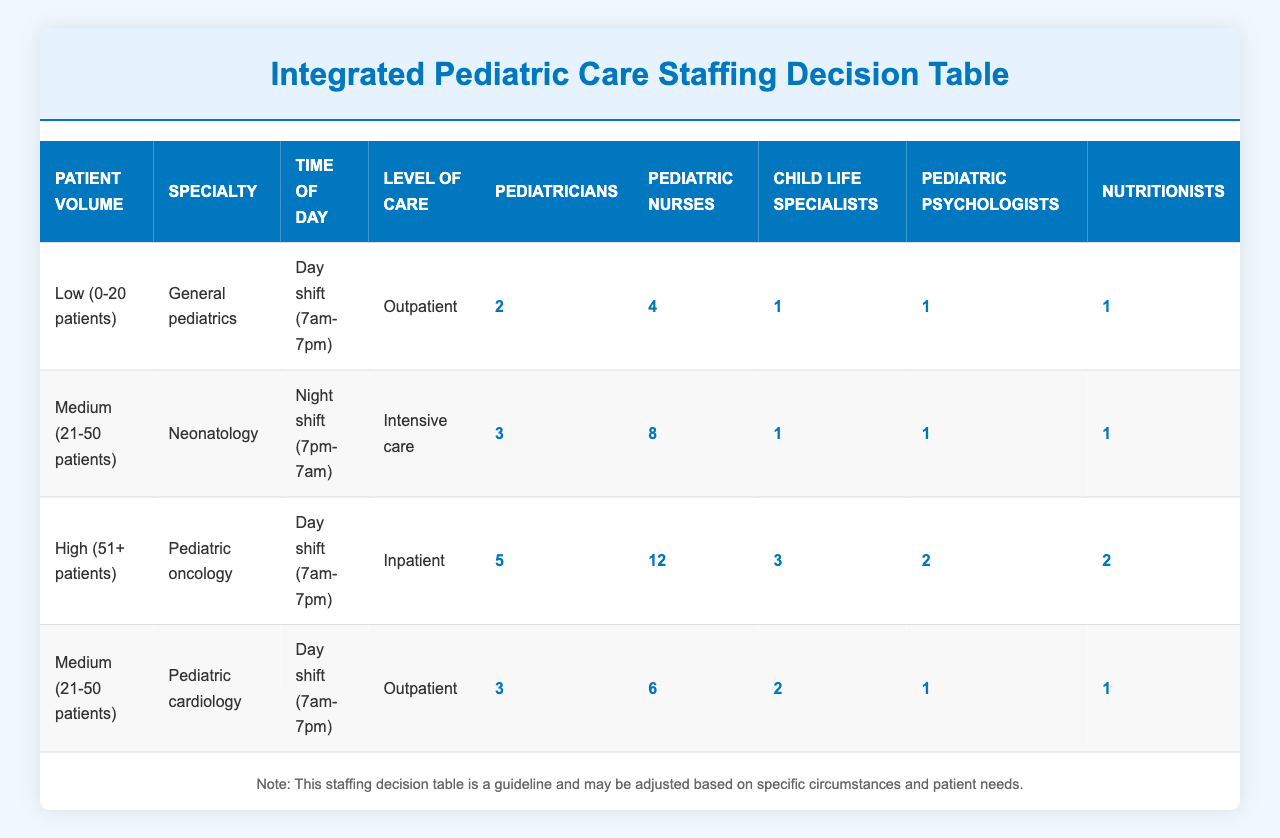What is the staffing allocation for pediatric psychologists during medium patient volume for pediatric cardiology? For medium patient volume (21-50 patients) in pediatric cardiology, the staffing table indicates that there is 1 pediatric psychologist allocated.
Answer: 1 How many pediatric nurses are needed for high patient volume in pediatric oncology? The table specifies that during high patient volume (51+ patients) in pediatric oncology, the required number of pediatric nurses is 12.
Answer: 12 Are there more pediatricians allocated for outpatient or inpatient care during the day shift? On the day shift, pediatricians allocated for outpatient care (low volume general pediatrics needs 2 and medium volume pediatric cardiology needs 3) total 5, whereas for inpatient care (high volume pediatric oncology) there are 5 pediatricians. Since both totals are equal at 5, the answer is no, there are not more pediatricians for either care level during the day shift.
Answer: No What is the combined total of child life specialists and nutritionists required during the medium patient volume in neonatal care? In the table, for medium patient volume (21-50 patients) during night shift in neonatal care, 1 child life specialist and 1 nutritionist are required. The total thus is 1 + 1 = 2.
Answer: 2 What is the difference in required pediatricians between low patient volume general pediatrics and high patient volume pediatric oncology? For low patient volume in general pediatrics, there are 2 pediatricians, and for high patient volume in pediatric oncology, there are 5 pediatricians. The difference in number is 5 - 2 = 3.
Answer: 3 Is it true that there are more pediatric psychologists needed for inpatient care than for outpatient care? The table shows that for inpatient care (high volume pediatric oncology), 2 pediatric psychologists are needed, while for outpatient care (low volume general pediatrics and medium volume pediatric cardiology), there is a maximum of 1 pediatric psychologist needed. Therefore, it is true that more pediatric psychologists are needed for inpatient care.
Answer: Yes How many staff members are there in total for pediatric oncology during the day shift? The staffing for high patient volume pediatric oncology during the day shift includes 5 pediatricians, 12 pediatric nurses, 3 child life specialists, 2 pediatric psychologists, and 2 nutritionists. Summing these gives 5 + 12 + 3 + 2 + 2 = 24 total staff members.
Answer: 24 Which specialty requires the highest number of pediatric nurses according to the table? The highest number of pediatric nurses according to the table is 12, allocated for pediatric oncology during high patient volume and day shift.
Answer: Pediatric oncology What is the average number of nutritionists required across all patient volumes and specialties? The staffing requirements from the table show that nutritionists are allocated as follows: 1 (low), 1 (medium, neonatology), 2 (high, oncology), and 1 (medium, cardiology), resulting in a total of 1 + 1 + 2 + 1 = 5 nutritionists. There are 4 data points, thus to find the average: 5/4 = 1.25.
Answer: 1.25 